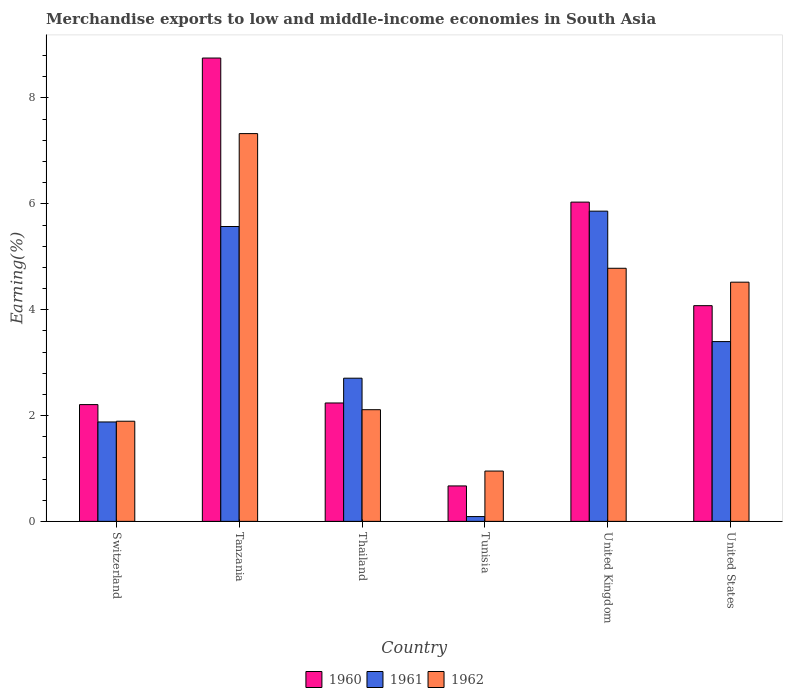How many bars are there on the 3rd tick from the left?
Give a very brief answer. 3. How many bars are there on the 4th tick from the right?
Keep it short and to the point. 3. What is the label of the 3rd group of bars from the left?
Offer a very short reply. Thailand. In how many cases, is the number of bars for a given country not equal to the number of legend labels?
Give a very brief answer. 0. What is the percentage of amount earned from merchandise exports in 1961 in United Kingdom?
Ensure brevity in your answer.  5.86. Across all countries, what is the maximum percentage of amount earned from merchandise exports in 1962?
Provide a succinct answer. 7.33. Across all countries, what is the minimum percentage of amount earned from merchandise exports in 1960?
Your response must be concise. 0.67. In which country was the percentage of amount earned from merchandise exports in 1962 maximum?
Make the answer very short. Tanzania. In which country was the percentage of amount earned from merchandise exports in 1960 minimum?
Keep it short and to the point. Tunisia. What is the total percentage of amount earned from merchandise exports in 1960 in the graph?
Provide a succinct answer. 23.98. What is the difference between the percentage of amount earned from merchandise exports in 1960 in Tunisia and that in United Kingdom?
Your answer should be compact. -5.36. What is the difference between the percentage of amount earned from merchandise exports in 1960 in Thailand and the percentage of amount earned from merchandise exports in 1962 in Switzerland?
Provide a succinct answer. 0.34. What is the average percentage of amount earned from merchandise exports in 1960 per country?
Your answer should be compact. 4. What is the difference between the percentage of amount earned from merchandise exports of/in 1960 and percentage of amount earned from merchandise exports of/in 1961 in United States?
Give a very brief answer. 0.68. What is the ratio of the percentage of amount earned from merchandise exports in 1960 in Thailand to that in United Kingdom?
Provide a succinct answer. 0.37. Is the percentage of amount earned from merchandise exports in 1961 in Thailand less than that in United Kingdom?
Offer a terse response. Yes. What is the difference between the highest and the second highest percentage of amount earned from merchandise exports in 1960?
Give a very brief answer. 4.68. What is the difference between the highest and the lowest percentage of amount earned from merchandise exports in 1962?
Provide a succinct answer. 6.38. In how many countries, is the percentage of amount earned from merchandise exports in 1960 greater than the average percentage of amount earned from merchandise exports in 1960 taken over all countries?
Offer a terse response. 3. Is the sum of the percentage of amount earned from merchandise exports in 1962 in Switzerland and Thailand greater than the maximum percentage of amount earned from merchandise exports in 1960 across all countries?
Your answer should be compact. No. What does the 2nd bar from the right in United Kingdom represents?
Provide a succinct answer. 1961. How many countries are there in the graph?
Provide a short and direct response. 6. Does the graph contain grids?
Your response must be concise. No. How are the legend labels stacked?
Your answer should be compact. Horizontal. What is the title of the graph?
Offer a very short reply. Merchandise exports to low and middle-income economies in South Asia. What is the label or title of the Y-axis?
Provide a succinct answer. Earning(%). What is the Earning(%) of 1960 in Switzerland?
Your response must be concise. 2.21. What is the Earning(%) of 1961 in Switzerland?
Your response must be concise. 1.88. What is the Earning(%) in 1962 in Switzerland?
Offer a terse response. 1.89. What is the Earning(%) of 1960 in Tanzania?
Offer a very short reply. 8.75. What is the Earning(%) of 1961 in Tanzania?
Provide a succinct answer. 5.57. What is the Earning(%) of 1962 in Tanzania?
Ensure brevity in your answer.  7.33. What is the Earning(%) in 1960 in Thailand?
Offer a terse response. 2.24. What is the Earning(%) of 1961 in Thailand?
Provide a short and direct response. 2.71. What is the Earning(%) in 1962 in Thailand?
Give a very brief answer. 2.11. What is the Earning(%) of 1960 in Tunisia?
Make the answer very short. 0.67. What is the Earning(%) in 1961 in Tunisia?
Your answer should be very brief. 0.09. What is the Earning(%) in 1962 in Tunisia?
Ensure brevity in your answer.  0.95. What is the Earning(%) in 1960 in United Kingdom?
Your response must be concise. 6.03. What is the Earning(%) in 1961 in United Kingdom?
Your answer should be compact. 5.86. What is the Earning(%) in 1962 in United Kingdom?
Give a very brief answer. 4.78. What is the Earning(%) of 1960 in United States?
Provide a succinct answer. 4.08. What is the Earning(%) in 1961 in United States?
Your answer should be very brief. 3.4. What is the Earning(%) in 1962 in United States?
Keep it short and to the point. 4.52. Across all countries, what is the maximum Earning(%) in 1960?
Your answer should be compact. 8.75. Across all countries, what is the maximum Earning(%) of 1961?
Your answer should be compact. 5.86. Across all countries, what is the maximum Earning(%) of 1962?
Your response must be concise. 7.33. Across all countries, what is the minimum Earning(%) of 1960?
Ensure brevity in your answer.  0.67. Across all countries, what is the minimum Earning(%) in 1961?
Offer a terse response. 0.09. Across all countries, what is the minimum Earning(%) in 1962?
Give a very brief answer. 0.95. What is the total Earning(%) of 1960 in the graph?
Give a very brief answer. 23.98. What is the total Earning(%) in 1961 in the graph?
Your response must be concise. 19.5. What is the total Earning(%) in 1962 in the graph?
Give a very brief answer. 21.58. What is the difference between the Earning(%) of 1960 in Switzerland and that in Tanzania?
Keep it short and to the point. -6.55. What is the difference between the Earning(%) of 1961 in Switzerland and that in Tanzania?
Offer a terse response. -3.69. What is the difference between the Earning(%) of 1962 in Switzerland and that in Tanzania?
Your response must be concise. -5.43. What is the difference between the Earning(%) of 1960 in Switzerland and that in Thailand?
Your answer should be very brief. -0.03. What is the difference between the Earning(%) in 1961 in Switzerland and that in Thailand?
Give a very brief answer. -0.83. What is the difference between the Earning(%) of 1962 in Switzerland and that in Thailand?
Ensure brevity in your answer.  -0.22. What is the difference between the Earning(%) in 1960 in Switzerland and that in Tunisia?
Your answer should be compact. 1.54. What is the difference between the Earning(%) of 1961 in Switzerland and that in Tunisia?
Your answer should be compact. 1.79. What is the difference between the Earning(%) of 1962 in Switzerland and that in Tunisia?
Make the answer very short. 0.94. What is the difference between the Earning(%) in 1960 in Switzerland and that in United Kingdom?
Give a very brief answer. -3.83. What is the difference between the Earning(%) of 1961 in Switzerland and that in United Kingdom?
Your answer should be very brief. -3.98. What is the difference between the Earning(%) in 1962 in Switzerland and that in United Kingdom?
Offer a very short reply. -2.89. What is the difference between the Earning(%) in 1960 in Switzerland and that in United States?
Your answer should be very brief. -1.87. What is the difference between the Earning(%) of 1961 in Switzerland and that in United States?
Make the answer very short. -1.52. What is the difference between the Earning(%) in 1962 in Switzerland and that in United States?
Ensure brevity in your answer.  -2.63. What is the difference between the Earning(%) in 1960 in Tanzania and that in Thailand?
Provide a short and direct response. 6.52. What is the difference between the Earning(%) of 1961 in Tanzania and that in Thailand?
Keep it short and to the point. 2.87. What is the difference between the Earning(%) in 1962 in Tanzania and that in Thailand?
Your answer should be compact. 5.22. What is the difference between the Earning(%) of 1960 in Tanzania and that in Tunisia?
Keep it short and to the point. 8.09. What is the difference between the Earning(%) of 1961 in Tanzania and that in Tunisia?
Ensure brevity in your answer.  5.48. What is the difference between the Earning(%) in 1962 in Tanzania and that in Tunisia?
Offer a terse response. 6.38. What is the difference between the Earning(%) in 1960 in Tanzania and that in United Kingdom?
Keep it short and to the point. 2.72. What is the difference between the Earning(%) in 1961 in Tanzania and that in United Kingdom?
Your response must be concise. -0.29. What is the difference between the Earning(%) in 1962 in Tanzania and that in United Kingdom?
Offer a terse response. 2.54. What is the difference between the Earning(%) in 1960 in Tanzania and that in United States?
Offer a very short reply. 4.68. What is the difference between the Earning(%) in 1961 in Tanzania and that in United States?
Ensure brevity in your answer.  2.17. What is the difference between the Earning(%) of 1962 in Tanzania and that in United States?
Your answer should be compact. 2.81. What is the difference between the Earning(%) of 1960 in Thailand and that in Tunisia?
Your response must be concise. 1.57. What is the difference between the Earning(%) in 1961 in Thailand and that in Tunisia?
Make the answer very short. 2.61. What is the difference between the Earning(%) in 1962 in Thailand and that in Tunisia?
Offer a terse response. 1.16. What is the difference between the Earning(%) of 1960 in Thailand and that in United Kingdom?
Your answer should be very brief. -3.8. What is the difference between the Earning(%) of 1961 in Thailand and that in United Kingdom?
Your answer should be compact. -3.16. What is the difference between the Earning(%) of 1962 in Thailand and that in United Kingdom?
Provide a short and direct response. -2.67. What is the difference between the Earning(%) in 1960 in Thailand and that in United States?
Your answer should be very brief. -1.84. What is the difference between the Earning(%) of 1961 in Thailand and that in United States?
Your answer should be compact. -0.69. What is the difference between the Earning(%) of 1962 in Thailand and that in United States?
Offer a very short reply. -2.41. What is the difference between the Earning(%) of 1960 in Tunisia and that in United Kingdom?
Make the answer very short. -5.36. What is the difference between the Earning(%) of 1961 in Tunisia and that in United Kingdom?
Your answer should be compact. -5.77. What is the difference between the Earning(%) in 1962 in Tunisia and that in United Kingdom?
Offer a terse response. -3.83. What is the difference between the Earning(%) of 1960 in Tunisia and that in United States?
Keep it short and to the point. -3.41. What is the difference between the Earning(%) of 1961 in Tunisia and that in United States?
Make the answer very short. -3.31. What is the difference between the Earning(%) in 1962 in Tunisia and that in United States?
Offer a very short reply. -3.57. What is the difference between the Earning(%) of 1960 in United Kingdom and that in United States?
Your response must be concise. 1.96. What is the difference between the Earning(%) in 1961 in United Kingdom and that in United States?
Ensure brevity in your answer.  2.46. What is the difference between the Earning(%) of 1962 in United Kingdom and that in United States?
Your answer should be very brief. 0.26. What is the difference between the Earning(%) of 1960 in Switzerland and the Earning(%) of 1961 in Tanzania?
Offer a very short reply. -3.37. What is the difference between the Earning(%) in 1960 in Switzerland and the Earning(%) in 1962 in Tanzania?
Offer a terse response. -5.12. What is the difference between the Earning(%) of 1961 in Switzerland and the Earning(%) of 1962 in Tanzania?
Offer a terse response. -5.45. What is the difference between the Earning(%) in 1960 in Switzerland and the Earning(%) in 1961 in Thailand?
Your response must be concise. -0.5. What is the difference between the Earning(%) in 1960 in Switzerland and the Earning(%) in 1962 in Thailand?
Ensure brevity in your answer.  0.1. What is the difference between the Earning(%) of 1961 in Switzerland and the Earning(%) of 1962 in Thailand?
Keep it short and to the point. -0.23. What is the difference between the Earning(%) of 1960 in Switzerland and the Earning(%) of 1961 in Tunisia?
Offer a terse response. 2.12. What is the difference between the Earning(%) of 1960 in Switzerland and the Earning(%) of 1962 in Tunisia?
Provide a short and direct response. 1.26. What is the difference between the Earning(%) in 1961 in Switzerland and the Earning(%) in 1962 in Tunisia?
Offer a terse response. 0.93. What is the difference between the Earning(%) in 1960 in Switzerland and the Earning(%) in 1961 in United Kingdom?
Your response must be concise. -3.66. What is the difference between the Earning(%) of 1960 in Switzerland and the Earning(%) of 1962 in United Kingdom?
Your response must be concise. -2.58. What is the difference between the Earning(%) in 1961 in Switzerland and the Earning(%) in 1962 in United Kingdom?
Offer a terse response. -2.9. What is the difference between the Earning(%) of 1960 in Switzerland and the Earning(%) of 1961 in United States?
Offer a very short reply. -1.19. What is the difference between the Earning(%) of 1960 in Switzerland and the Earning(%) of 1962 in United States?
Ensure brevity in your answer.  -2.31. What is the difference between the Earning(%) of 1961 in Switzerland and the Earning(%) of 1962 in United States?
Keep it short and to the point. -2.64. What is the difference between the Earning(%) in 1960 in Tanzania and the Earning(%) in 1961 in Thailand?
Make the answer very short. 6.05. What is the difference between the Earning(%) in 1960 in Tanzania and the Earning(%) in 1962 in Thailand?
Provide a succinct answer. 6.64. What is the difference between the Earning(%) in 1961 in Tanzania and the Earning(%) in 1962 in Thailand?
Your answer should be very brief. 3.46. What is the difference between the Earning(%) in 1960 in Tanzania and the Earning(%) in 1961 in Tunisia?
Give a very brief answer. 8.66. What is the difference between the Earning(%) of 1960 in Tanzania and the Earning(%) of 1962 in Tunisia?
Offer a terse response. 7.8. What is the difference between the Earning(%) of 1961 in Tanzania and the Earning(%) of 1962 in Tunisia?
Give a very brief answer. 4.62. What is the difference between the Earning(%) in 1960 in Tanzania and the Earning(%) in 1961 in United Kingdom?
Provide a succinct answer. 2.89. What is the difference between the Earning(%) of 1960 in Tanzania and the Earning(%) of 1962 in United Kingdom?
Offer a terse response. 3.97. What is the difference between the Earning(%) in 1961 in Tanzania and the Earning(%) in 1962 in United Kingdom?
Your response must be concise. 0.79. What is the difference between the Earning(%) of 1960 in Tanzania and the Earning(%) of 1961 in United States?
Give a very brief answer. 5.36. What is the difference between the Earning(%) of 1960 in Tanzania and the Earning(%) of 1962 in United States?
Offer a very short reply. 4.24. What is the difference between the Earning(%) of 1961 in Tanzania and the Earning(%) of 1962 in United States?
Your response must be concise. 1.05. What is the difference between the Earning(%) of 1960 in Thailand and the Earning(%) of 1961 in Tunisia?
Your answer should be compact. 2.15. What is the difference between the Earning(%) of 1960 in Thailand and the Earning(%) of 1962 in Tunisia?
Ensure brevity in your answer.  1.29. What is the difference between the Earning(%) of 1961 in Thailand and the Earning(%) of 1962 in Tunisia?
Give a very brief answer. 1.75. What is the difference between the Earning(%) of 1960 in Thailand and the Earning(%) of 1961 in United Kingdom?
Your response must be concise. -3.62. What is the difference between the Earning(%) of 1960 in Thailand and the Earning(%) of 1962 in United Kingdom?
Give a very brief answer. -2.55. What is the difference between the Earning(%) of 1961 in Thailand and the Earning(%) of 1962 in United Kingdom?
Offer a very short reply. -2.08. What is the difference between the Earning(%) of 1960 in Thailand and the Earning(%) of 1961 in United States?
Offer a very short reply. -1.16. What is the difference between the Earning(%) of 1960 in Thailand and the Earning(%) of 1962 in United States?
Offer a very short reply. -2.28. What is the difference between the Earning(%) in 1961 in Thailand and the Earning(%) in 1962 in United States?
Ensure brevity in your answer.  -1.81. What is the difference between the Earning(%) in 1960 in Tunisia and the Earning(%) in 1961 in United Kingdom?
Your answer should be compact. -5.19. What is the difference between the Earning(%) in 1960 in Tunisia and the Earning(%) in 1962 in United Kingdom?
Keep it short and to the point. -4.11. What is the difference between the Earning(%) of 1961 in Tunisia and the Earning(%) of 1962 in United Kingdom?
Ensure brevity in your answer.  -4.69. What is the difference between the Earning(%) of 1960 in Tunisia and the Earning(%) of 1961 in United States?
Offer a very short reply. -2.73. What is the difference between the Earning(%) in 1960 in Tunisia and the Earning(%) in 1962 in United States?
Provide a succinct answer. -3.85. What is the difference between the Earning(%) in 1961 in Tunisia and the Earning(%) in 1962 in United States?
Make the answer very short. -4.43. What is the difference between the Earning(%) in 1960 in United Kingdom and the Earning(%) in 1961 in United States?
Provide a succinct answer. 2.64. What is the difference between the Earning(%) of 1960 in United Kingdom and the Earning(%) of 1962 in United States?
Offer a terse response. 1.51. What is the difference between the Earning(%) in 1961 in United Kingdom and the Earning(%) in 1962 in United States?
Your answer should be compact. 1.34. What is the average Earning(%) of 1960 per country?
Keep it short and to the point. 4. What is the average Earning(%) in 1961 per country?
Ensure brevity in your answer.  3.25. What is the average Earning(%) of 1962 per country?
Provide a short and direct response. 3.6. What is the difference between the Earning(%) of 1960 and Earning(%) of 1961 in Switzerland?
Provide a succinct answer. 0.33. What is the difference between the Earning(%) of 1960 and Earning(%) of 1962 in Switzerland?
Provide a short and direct response. 0.31. What is the difference between the Earning(%) in 1961 and Earning(%) in 1962 in Switzerland?
Ensure brevity in your answer.  -0.01. What is the difference between the Earning(%) of 1960 and Earning(%) of 1961 in Tanzania?
Keep it short and to the point. 3.18. What is the difference between the Earning(%) in 1960 and Earning(%) in 1962 in Tanzania?
Give a very brief answer. 1.43. What is the difference between the Earning(%) in 1961 and Earning(%) in 1962 in Tanzania?
Your answer should be compact. -1.76. What is the difference between the Earning(%) of 1960 and Earning(%) of 1961 in Thailand?
Keep it short and to the point. -0.47. What is the difference between the Earning(%) in 1960 and Earning(%) in 1962 in Thailand?
Your answer should be compact. 0.13. What is the difference between the Earning(%) of 1961 and Earning(%) of 1962 in Thailand?
Provide a short and direct response. 0.6. What is the difference between the Earning(%) in 1960 and Earning(%) in 1961 in Tunisia?
Provide a succinct answer. 0.58. What is the difference between the Earning(%) of 1960 and Earning(%) of 1962 in Tunisia?
Give a very brief answer. -0.28. What is the difference between the Earning(%) of 1961 and Earning(%) of 1962 in Tunisia?
Your answer should be compact. -0.86. What is the difference between the Earning(%) of 1960 and Earning(%) of 1961 in United Kingdom?
Provide a short and direct response. 0.17. What is the difference between the Earning(%) in 1960 and Earning(%) in 1962 in United Kingdom?
Offer a very short reply. 1.25. What is the difference between the Earning(%) of 1961 and Earning(%) of 1962 in United Kingdom?
Give a very brief answer. 1.08. What is the difference between the Earning(%) in 1960 and Earning(%) in 1961 in United States?
Your response must be concise. 0.68. What is the difference between the Earning(%) in 1960 and Earning(%) in 1962 in United States?
Give a very brief answer. -0.44. What is the difference between the Earning(%) of 1961 and Earning(%) of 1962 in United States?
Give a very brief answer. -1.12. What is the ratio of the Earning(%) of 1960 in Switzerland to that in Tanzania?
Ensure brevity in your answer.  0.25. What is the ratio of the Earning(%) in 1961 in Switzerland to that in Tanzania?
Offer a very short reply. 0.34. What is the ratio of the Earning(%) in 1962 in Switzerland to that in Tanzania?
Offer a very short reply. 0.26. What is the ratio of the Earning(%) in 1960 in Switzerland to that in Thailand?
Offer a terse response. 0.99. What is the ratio of the Earning(%) of 1961 in Switzerland to that in Thailand?
Give a very brief answer. 0.69. What is the ratio of the Earning(%) of 1962 in Switzerland to that in Thailand?
Offer a terse response. 0.9. What is the ratio of the Earning(%) of 1960 in Switzerland to that in Tunisia?
Your answer should be very brief. 3.3. What is the ratio of the Earning(%) of 1961 in Switzerland to that in Tunisia?
Give a very brief answer. 20.72. What is the ratio of the Earning(%) of 1962 in Switzerland to that in Tunisia?
Your answer should be very brief. 1.99. What is the ratio of the Earning(%) in 1960 in Switzerland to that in United Kingdom?
Make the answer very short. 0.37. What is the ratio of the Earning(%) of 1961 in Switzerland to that in United Kingdom?
Provide a succinct answer. 0.32. What is the ratio of the Earning(%) in 1962 in Switzerland to that in United Kingdom?
Your response must be concise. 0.4. What is the ratio of the Earning(%) in 1960 in Switzerland to that in United States?
Your answer should be very brief. 0.54. What is the ratio of the Earning(%) of 1961 in Switzerland to that in United States?
Your answer should be compact. 0.55. What is the ratio of the Earning(%) in 1962 in Switzerland to that in United States?
Provide a succinct answer. 0.42. What is the ratio of the Earning(%) in 1960 in Tanzania to that in Thailand?
Give a very brief answer. 3.91. What is the ratio of the Earning(%) in 1961 in Tanzania to that in Thailand?
Make the answer very short. 2.06. What is the ratio of the Earning(%) of 1962 in Tanzania to that in Thailand?
Your answer should be very brief. 3.47. What is the ratio of the Earning(%) of 1960 in Tanzania to that in Tunisia?
Offer a terse response. 13.08. What is the ratio of the Earning(%) in 1961 in Tanzania to that in Tunisia?
Your answer should be very brief. 61.46. What is the ratio of the Earning(%) in 1962 in Tanzania to that in Tunisia?
Offer a terse response. 7.71. What is the ratio of the Earning(%) of 1960 in Tanzania to that in United Kingdom?
Your answer should be compact. 1.45. What is the ratio of the Earning(%) of 1961 in Tanzania to that in United Kingdom?
Ensure brevity in your answer.  0.95. What is the ratio of the Earning(%) of 1962 in Tanzania to that in United Kingdom?
Provide a succinct answer. 1.53. What is the ratio of the Earning(%) in 1960 in Tanzania to that in United States?
Your answer should be very brief. 2.15. What is the ratio of the Earning(%) in 1961 in Tanzania to that in United States?
Make the answer very short. 1.64. What is the ratio of the Earning(%) in 1962 in Tanzania to that in United States?
Ensure brevity in your answer.  1.62. What is the ratio of the Earning(%) in 1960 in Thailand to that in Tunisia?
Make the answer very short. 3.34. What is the ratio of the Earning(%) in 1961 in Thailand to that in Tunisia?
Provide a short and direct response. 29.84. What is the ratio of the Earning(%) of 1962 in Thailand to that in Tunisia?
Ensure brevity in your answer.  2.22. What is the ratio of the Earning(%) in 1960 in Thailand to that in United Kingdom?
Ensure brevity in your answer.  0.37. What is the ratio of the Earning(%) in 1961 in Thailand to that in United Kingdom?
Ensure brevity in your answer.  0.46. What is the ratio of the Earning(%) in 1962 in Thailand to that in United Kingdom?
Offer a very short reply. 0.44. What is the ratio of the Earning(%) of 1960 in Thailand to that in United States?
Keep it short and to the point. 0.55. What is the ratio of the Earning(%) of 1961 in Thailand to that in United States?
Make the answer very short. 0.8. What is the ratio of the Earning(%) of 1962 in Thailand to that in United States?
Offer a very short reply. 0.47. What is the ratio of the Earning(%) in 1960 in Tunisia to that in United Kingdom?
Keep it short and to the point. 0.11. What is the ratio of the Earning(%) of 1961 in Tunisia to that in United Kingdom?
Offer a terse response. 0.02. What is the ratio of the Earning(%) in 1962 in Tunisia to that in United Kingdom?
Ensure brevity in your answer.  0.2. What is the ratio of the Earning(%) in 1960 in Tunisia to that in United States?
Offer a very short reply. 0.16. What is the ratio of the Earning(%) in 1961 in Tunisia to that in United States?
Keep it short and to the point. 0.03. What is the ratio of the Earning(%) in 1962 in Tunisia to that in United States?
Keep it short and to the point. 0.21. What is the ratio of the Earning(%) of 1960 in United Kingdom to that in United States?
Offer a terse response. 1.48. What is the ratio of the Earning(%) of 1961 in United Kingdom to that in United States?
Your answer should be compact. 1.73. What is the ratio of the Earning(%) in 1962 in United Kingdom to that in United States?
Your response must be concise. 1.06. What is the difference between the highest and the second highest Earning(%) in 1960?
Keep it short and to the point. 2.72. What is the difference between the highest and the second highest Earning(%) in 1961?
Your response must be concise. 0.29. What is the difference between the highest and the second highest Earning(%) in 1962?
Provide a short and direct response. 2.54. What is the difference between the highest and the lowest Earning(%) of 1960?
Your response must be concise. 8.09. What is the difference between the highest and the lowest Earning(%) of 1961?
Give a very brief answer. 5.77. What is the difference between the highest and the lowest Earning(%) of 1962?
Give a very brief answer. 6.38. 